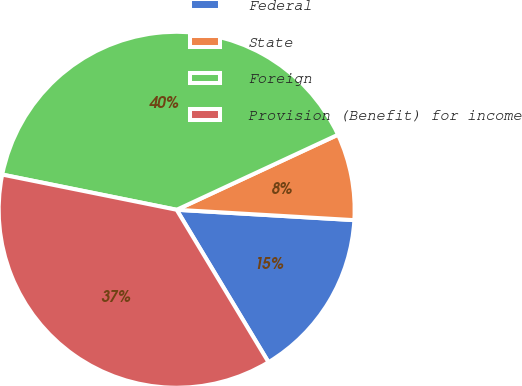Convert chart. <chart><loc_0><loc_0><loc_500><loc_500><pie_chart><fcel>Federal<fcel>State<fcel>Foreign<fcel>Provision (Benefit) for income<nl><fcel>15.44%<fcel>7.86%<fcel>39.9%<fcel>36.8%<nl></chart> 